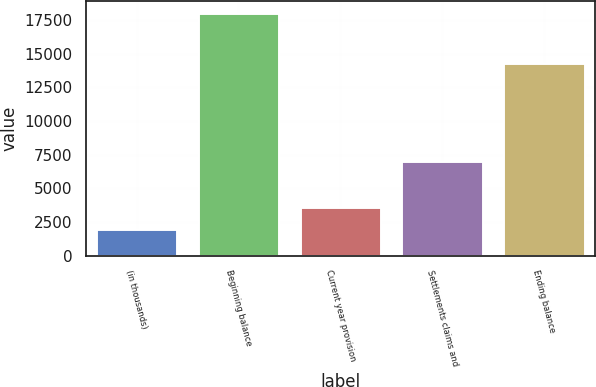Convert chart. <chart><loc_0><loc_0><loc_500><loc_500><bar_chart><fcel>(in thousands)<fcel>Beginning balance<fcel>Current year provision<fcel>Settlements claims and<fcel>Ending balance<nl><fcel>2008<fcel>18000<fcel>3607.2<fcel>7064<fcel>14300<nl></chart> 